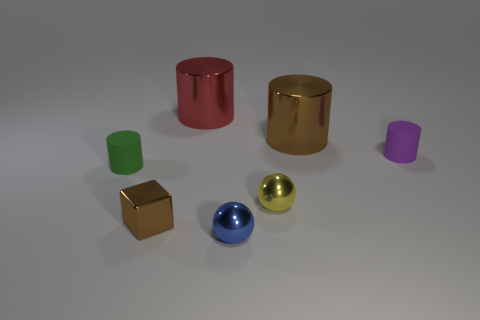Subtract all cyan cylinders. Subtract all red cubes. How many cylinders are left? 4 Add 1 small red matte cylinders. How many objects exist? 8 Subtract all cylinders. How many objects are left? 3 Add 5 big brown metallic things. How many big brown metallic things exist? 6 Subtract 1 yellow balls. How many objects are left? 6 Subtract all big metal cylinders. Subtract all small matte cylinders. How many objects are left? 3 Add 2 green rubber cylinders. How many green rubber cylinders are left? 3 